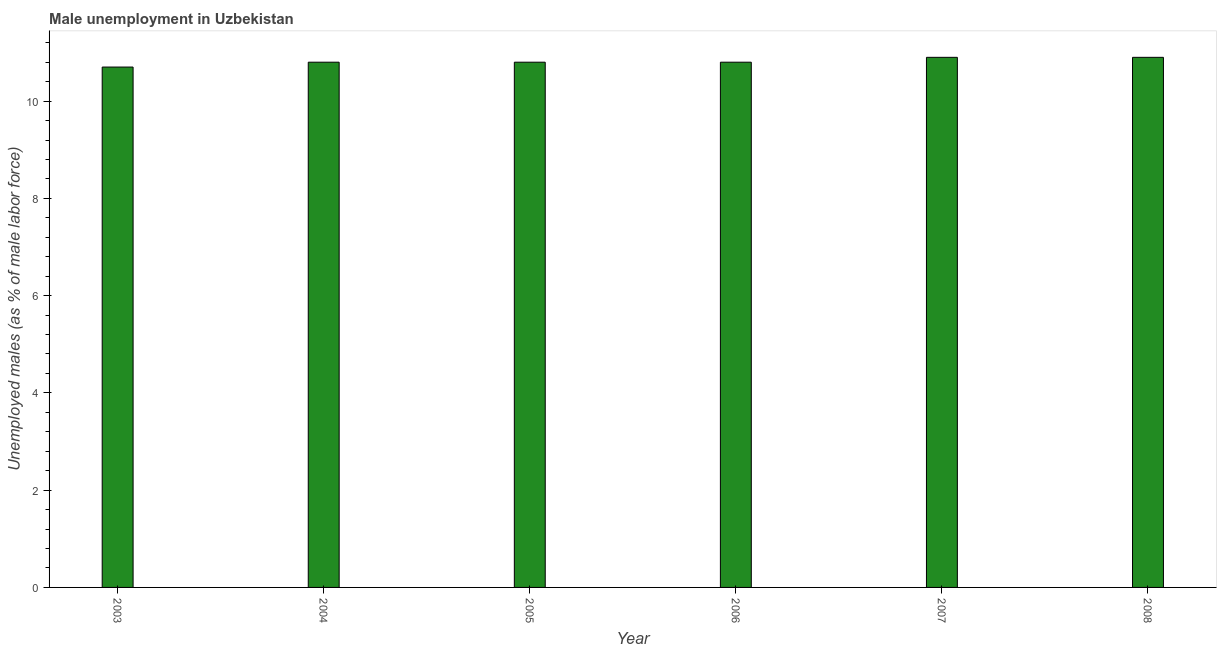Does the graph contain any zero values?
Ensure brevity in your answer.  No. What is the title of the graph?
Your answer should be compact. Male unemployment in Uzbekistan. What is the label or title of the Y-axis?
Your response must be concise. Unemployed males (as % of male labor force). What is the unemployed males population in 2004?
Give a very brief answer. 10.8. Across all years, what is the maximum unemployed males population?
Offer a terse response. 10.9. Across all years, what is the minimum unemployed males population?
Your answer should be compact. 10.7. What is the sum of the unemployed males population?
Ensure brevity in your answer.  64.9. What is the average unemployed males population per year?
Ensure brevity in your answer.  10.82. What is the median unemployed males population?
Your answer should be compact. 10.8. In how many years, is the unemployed males population greater than 0.4 %?
Offer a terse response. 6. Is the unemployed males population in 2003 less than that in 2004?
Offer a very short reply. Yes. Is the difference between the unemployed males population in 2005 and 2008 greater than the difference between any two years?
Keep it short and to the point. No. In how many years, is the unemployed males population greater than the average unemployed males population taken over all years?
Provide a succinct answer. 2. Are all the bars in the graph horizontal?
Make the answer very short. No. How many years are there in the graph?
Offer a very short reply. 6. What is the difference between two consecutive major ticks on the Y-axis?
Keep it short and to the point. 2. Are the values on the major ticks of Y-axis written in scientific E-notation?
Offer a terse response. No. What is the Unemployed males (as % of male labor force) of 2003?
Make the answer very short. 10.7. What is the Unemployed males (as % of male labor force) in 2004?
Your answer should be compact. 10.8. What is the Unemployed males (as % of male labor force) in 2005?
Ensure brevity in your answer.  10.8. What is the Unemployed males (as % of male labor force) of 2006?
Keep it short and to the point. 10.8. What is the Unemployed males (as % of male labor force) of 2007?
Provide a succinct answer. 10.9. What is the Unemployed males (as % of male labor force) in 2008?
Your answer should be very brief. 10.9. What is the difference between the Unemployed males (as % of male labor force) in 2003 and 2004?
Offer a very short reply. -0.1. What is the difference between the Unemployed males (as % of male labor force) in 2003 and 2006?
Your answer should be compact. -0.1. What is the difference between the Unemployed males (as % of male labor force) in 2003 and 2007?
Ensure brevity in your answer.  -0.2. What is the difference between the Unemployed males (as % of male labor force) in 2004 and 2007?
Give a very brief answer. -0.1. What is the difference between the Unemployed males (as % of male labor force) in 2004 and 2008?
Provide a succinct answer. -0.1. What is the difference between the Unemployed males (as % of male labor force) in 2005 and 2007?
Provide a short and direct response. -0.1. What is the difference between the Unemployed males (as % of male labor force) in 2006 and 2007?
Offer a very short reply. -0.1. What is the difference between the Unemployed males (as % of male labor force) in 2006 and 2008?
Make the answer very short. -0.1. What is the ratio of the Unemployed males (as % of male labor force) in 2003 to that in 2005?
Give a very brief answer. 0.99. What is the ratio of the Unemployed males (as % of male labor force) in 2003 to that in 2006?
Provide a succinct answer. 0.99. What is the ratio of the Unemployed males (as % of male labor force) in 2003 to that in 2008?
Keep it short and to the point. 0.98. What is the ratio of the Unemployed males (as % of male labor force) in 2004 to that in 2005?
Your response must be concise. 1. What is the ratio of the Unemployed males (as % of male labor force) in 2004 to that in 2006?
Ensure brevity in your answer.  1. What is the ratio of the Unemployed males (as % of male labor force) in 2004 to that in 2007?
Your response must be concise. 0.99. What is the ratio of the Unemployed males (as % of male labor force) in 2005 to that in 2006?
Your response must be concise. 1. What is the ratio of the Unemployed males (as % of male labor force) in 2005 to that in 2007?
Your answer should be very brief. 0.99. What is the ratio of the Unemployed males (as % of male labor force) in 2006 to that in 2007?
Offer a very short reply. 0.99. 